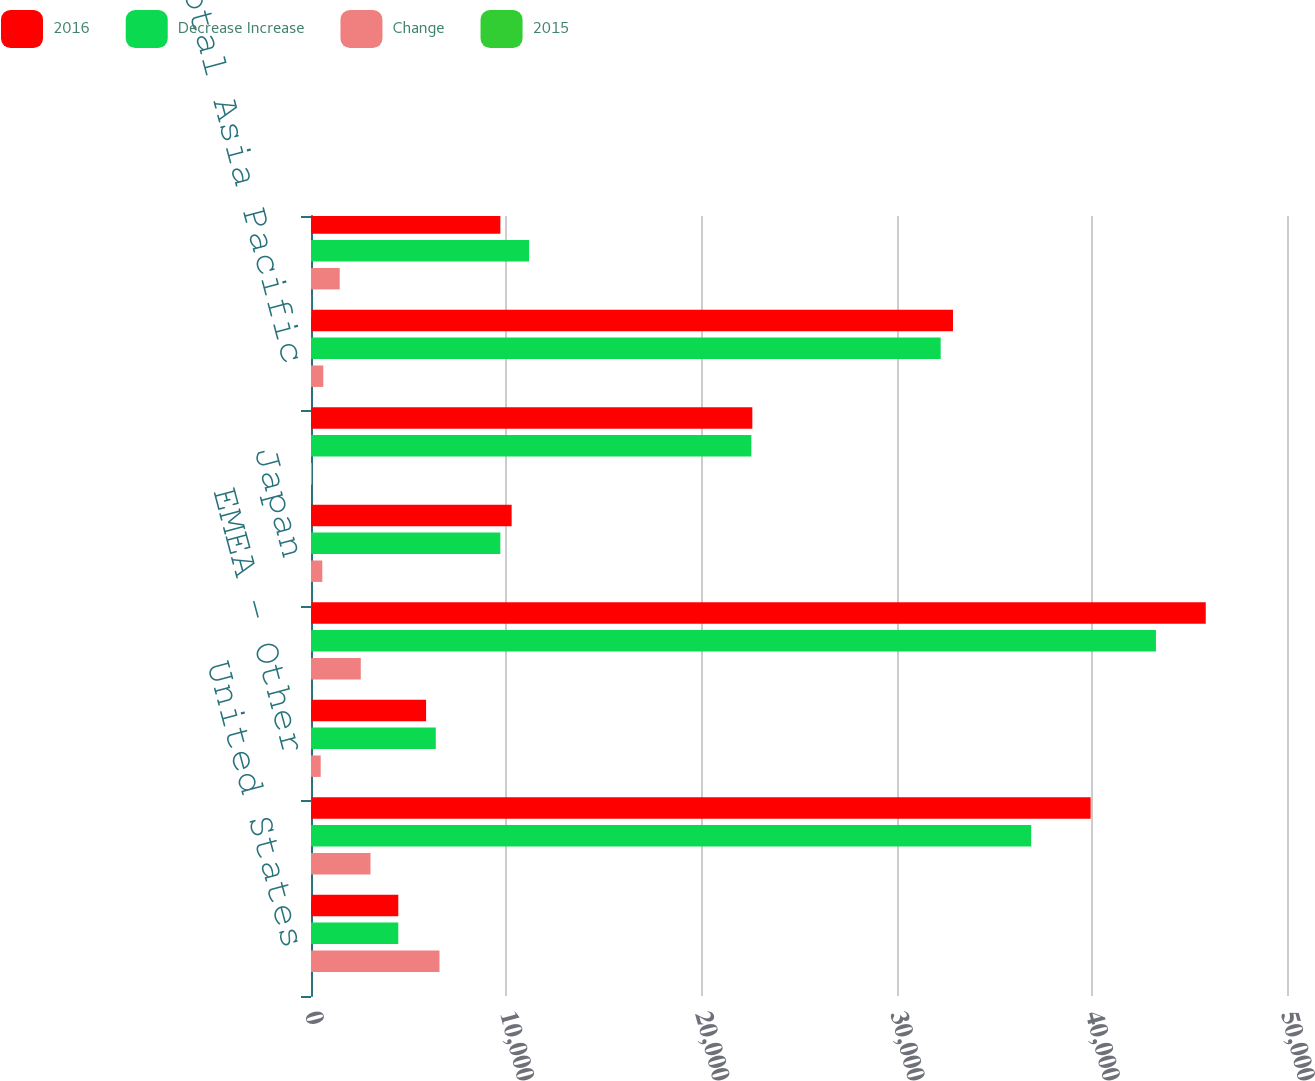<chart> <loc_0><loc_0><loc_500><loc_500><stacked_bar_chart><ecel><fcel>United States<fcel>Europe (b)<fcel>EMEA - Other<fcel>Total EMEA<fcel>Japan<fcel>Asia Pacific - Other<fcel>Total Asia Pacific<fcel>Latin America<nl><fcel>2016<fcel>4472<fcel>39942<fcel>5896<fcel>45838<fcel>10279<fcel>22610<fcel>32889<fcel>9701<nl><fcel>Decrease Increase<fcel>4472<fcel>36894<fcel>6393<fcel>43287<fcel>9700<fcel>22558<fcel>32258<fcel>11173<nl><fcel>Change<fcel>6582<fcel>3048<fcel>497<fcel>2551<fcel>579<fcel>52<fcel>631<fcel>1472<nl><fcel>2015<fcel>3.9<fcel>8.3<fcel>7.8<fcel>5.9<fcel>6<fcel>0.2<fcel>2<fcel>13.2<nl></chart> 